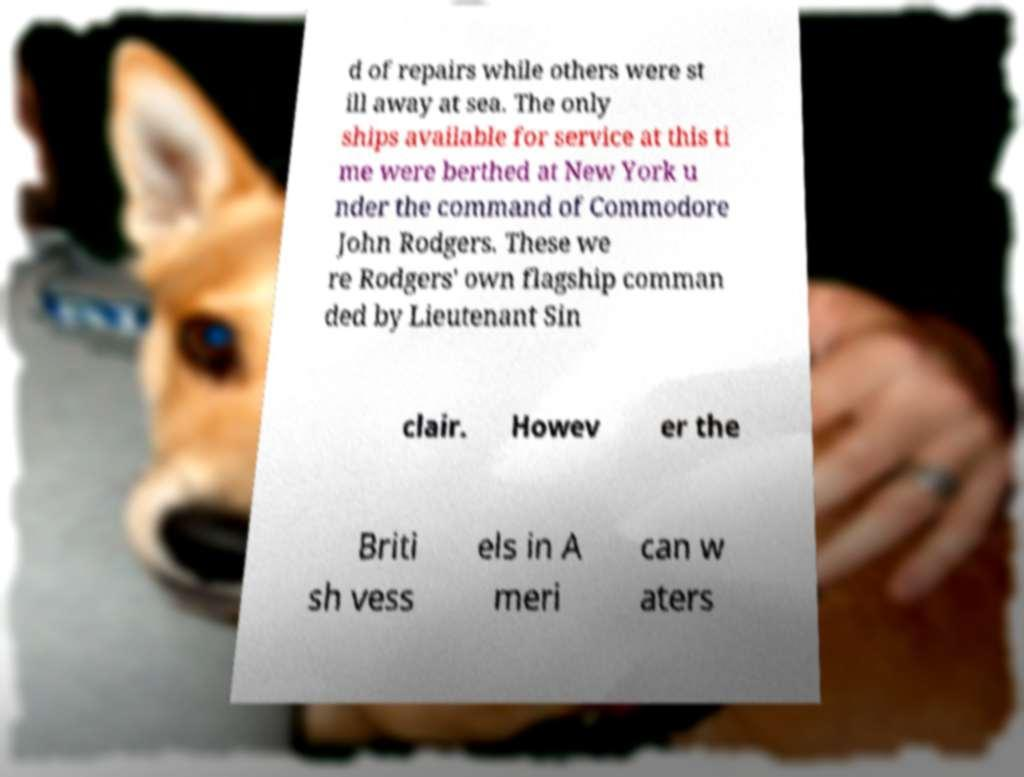Could you extract and type out the text from this image? d of repairs while others were st ill away at sea. The only ships available for service at this ti me were berthed at New York u nder the command of Commodore John Rodgers. These we re Rodgers' own flagship comman ded by Lieutenant Sin clair. Howev er the Briti sh vess els in A meri can w aters 